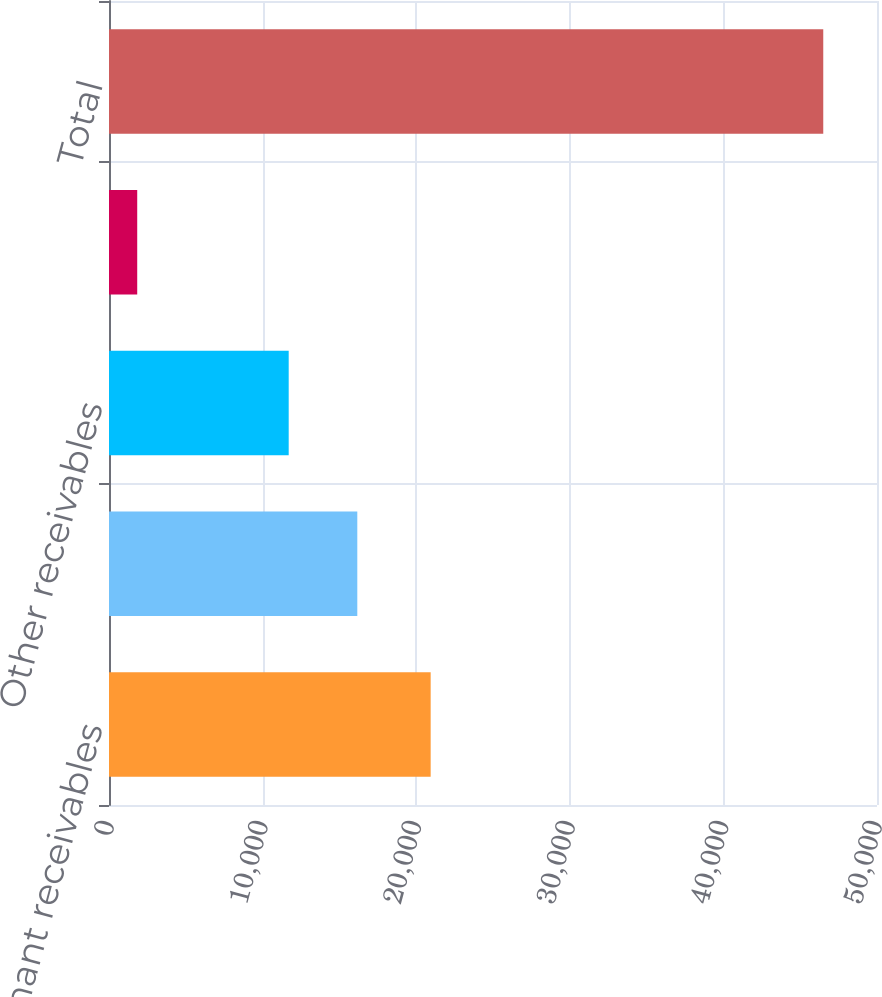Convert chart to OTSL. <chart><loc_0><loc_0><loc_500><loc_500><bar_chart><fcel>Tenant receivables<fcel>CAM and tax reimbursements<fcel>Other receivables<fcel>Less allowance for doubtful<fcel>Total<nl><fcel>20942<fcel>16165.4<fcel>11699<fcel>1837<fcel>46501<nl></chart> 